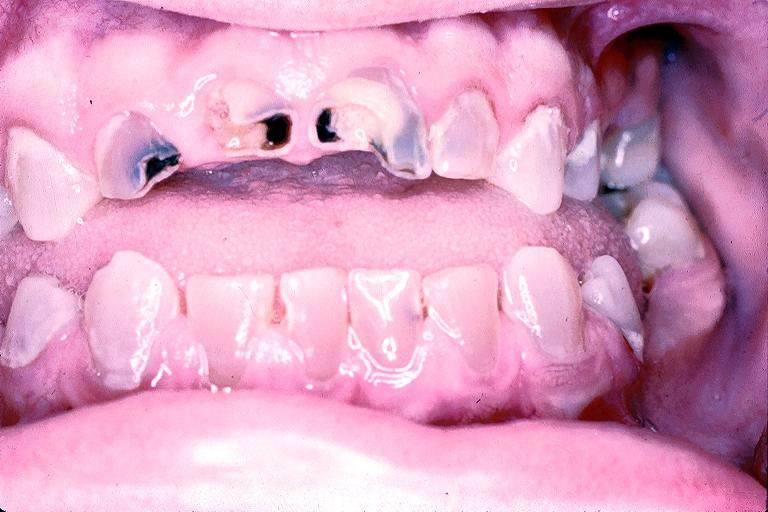does this image show dentinogenesis imperfecta?
Answer the question using a single word or phrase. Yes 